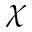Convert formula to latex. <formula><loc_0><loc_0><loc_500><loc_500>\chi</formula> 